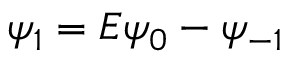<formula> <loc_0><loc_0><loc_500><loc_500>\psi _ { 1 } = E \psi _ { 0 } - \psi _ { - 1 }</formula> 